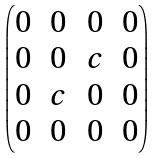<formula> <loc_0><loc_0><loc_500><loc_500>\begin{pmatrix} 0 & 0 & 0 & 0 \\ 0 & 0 & c & 0 \\ 0 & c & 0 & 0 \\ 0 & 0 & 0 & 0 \end{pmatrix}</formula> 